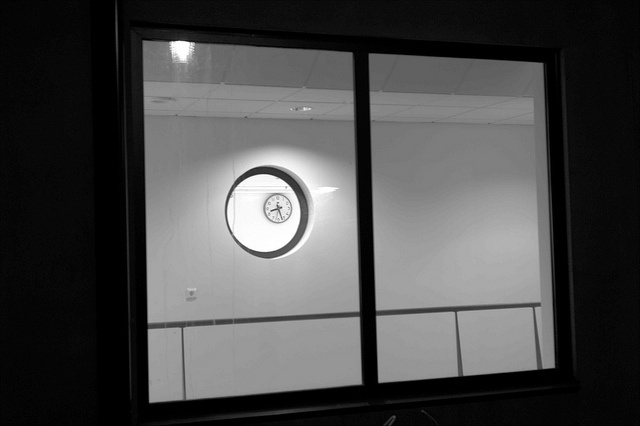Describe the objects in this image and their specific colors. I can see a clock in black, lightgray, darkgray, and dimgray tones in this image. 